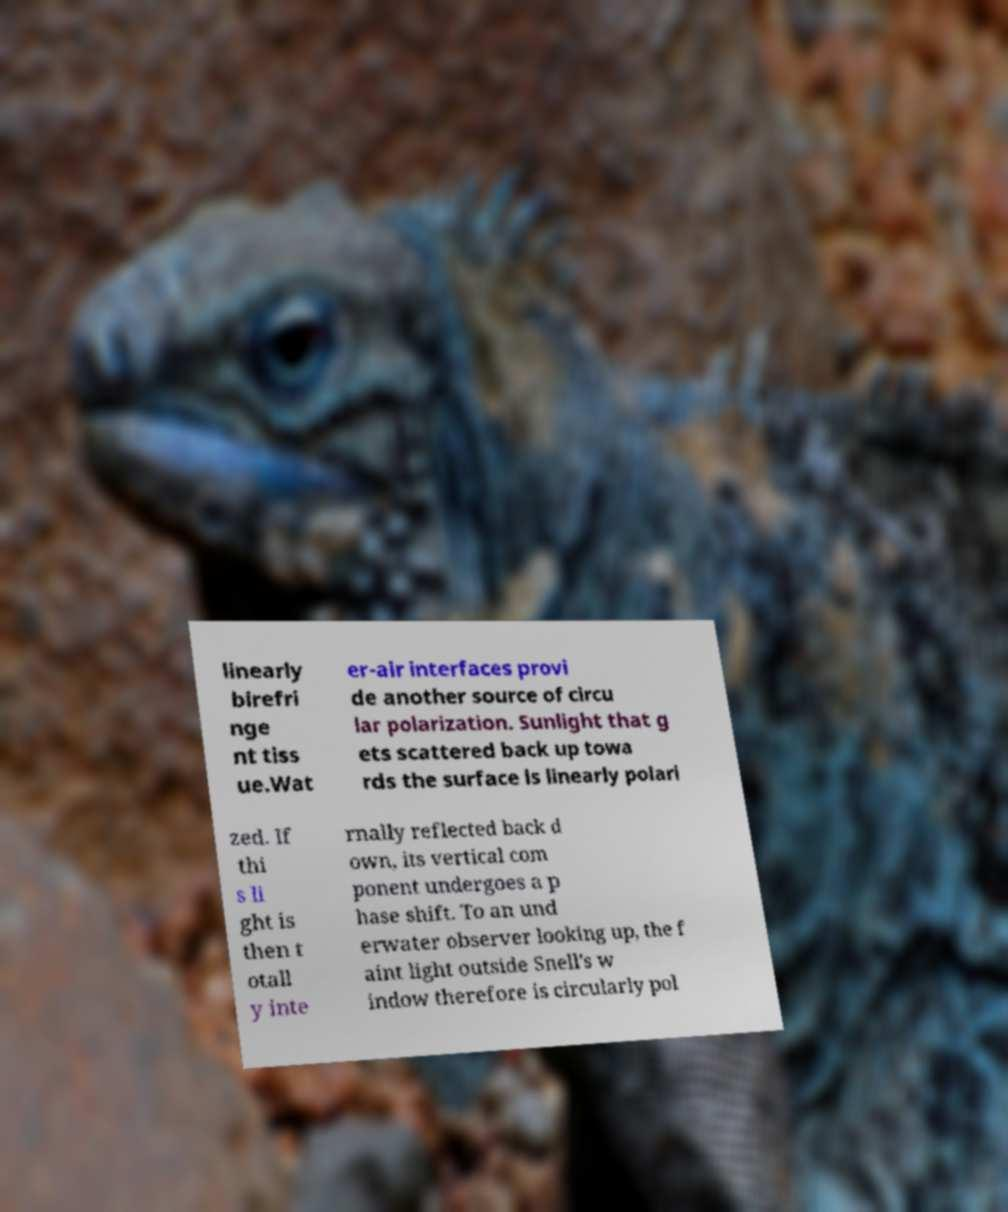Could you extract and type out the text from this image? linearly birefri nge nt tiss ue.Wat er-air interfaces provi de another source of circu lar polarization. Sunlight that g ets scattered back up towa rds the surface is linearly polari zed. If thi s li ght is then t otall y inte rnally reflected back d own, its vertical com ponent undergoes a p hase shift. To an und erwater observer looking up, the f aint light outside Snell's w indow therefore is circularly pol 